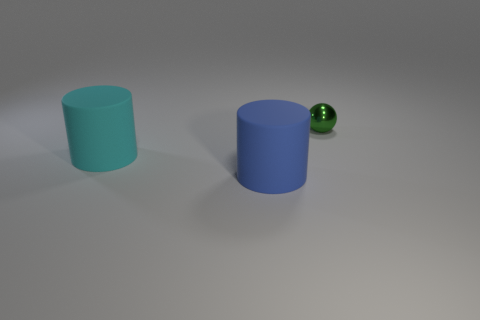Add 1 brown rubber things. How many objects exist? 4 Subtract all cylinders. How many objects are left? 1 Subtract all small yellow matte blocks. Subtract all large cyan cylinders. How many objects are left? 2 Add 1 rubber things. How many rubber things are left? 3 Add 1 large cyan matte things. How many large cyan matte things exist? 2 Subtract 0 yellow cubes. How many objects are left? 3 